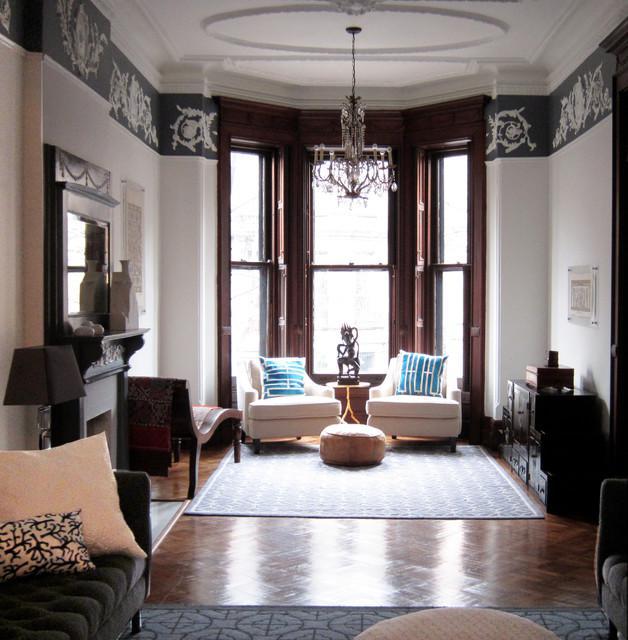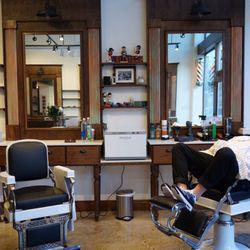The first image is the image on the left, the second image is the image on the right. For the images displayed, is the sentence "The left image features at least one empty back-turned black barber chair in front of a rectangular mirror." factually correct? Answer yes or no. No. 